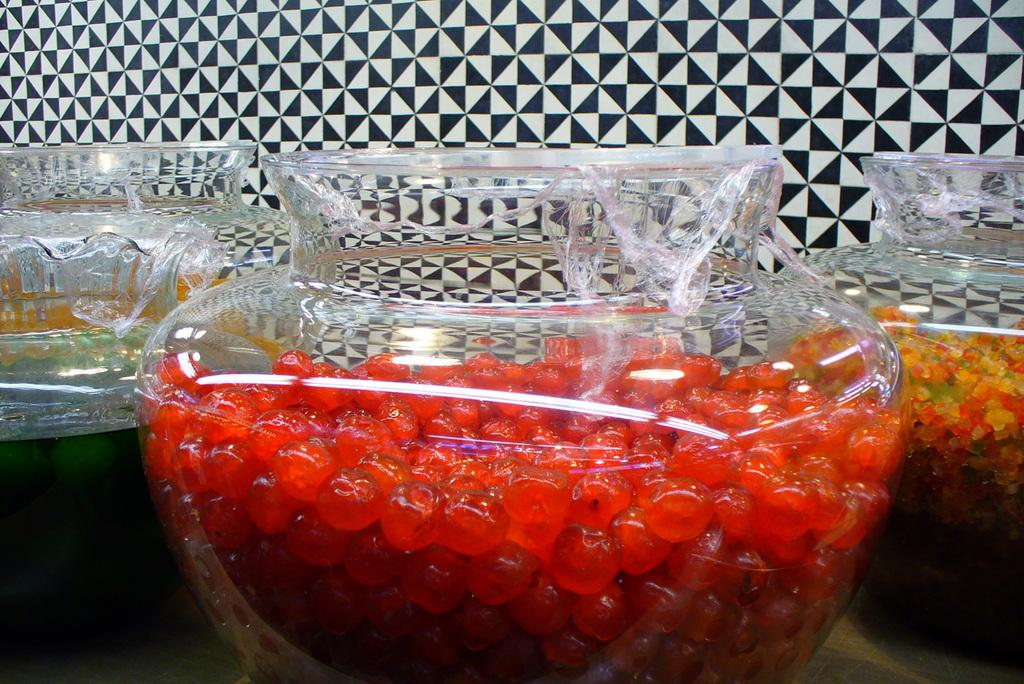What type of container is present in the image? There is a glass bowl in the image. What is inside the glass bowl? The glass bowl contains eatable things. What is the surface at the bottom of the image used for? The surface at the bottom of the image is not specified, but it could be a table or countertop. What can be seen in the background of the image? There is a wall visible in the background of the image. What type of fruit is being discussed in the image? There is no fruit mentioned or depicted in the image. How does the society depicted in the image influence the flavor of the eatable things in the glass bowl? There is no society or flavor mentioned in the image; it only shows a glass bowl with eatable things and a wall in the background. 